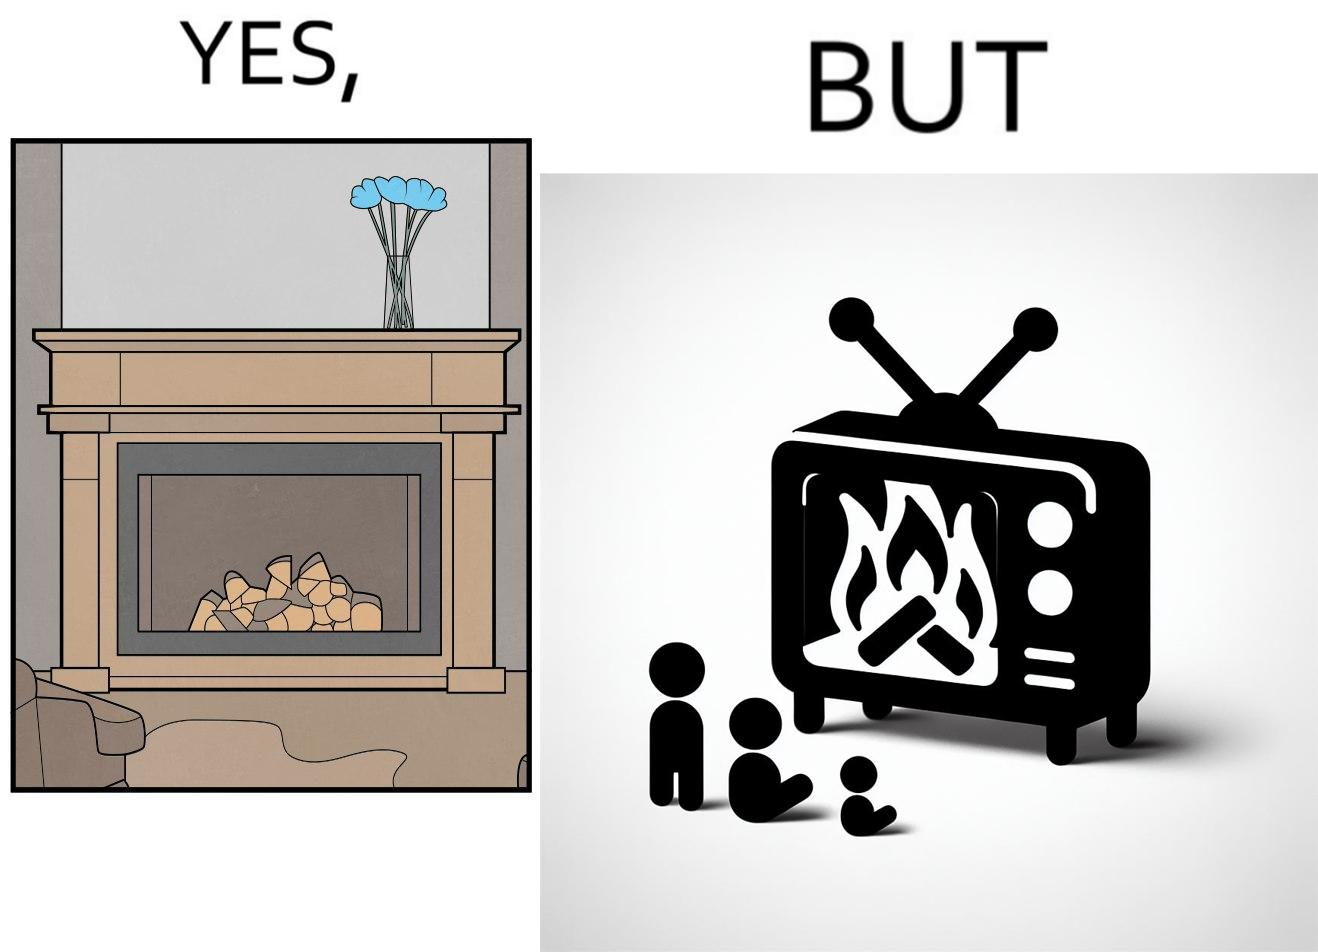Explain the humor or irony in this image. The images are funny since they show how even though real fireplaces exist, people choose to be lazy and watch fireplaces on television because they dont want the inconveniences of cleaning up, etc. afterwards 